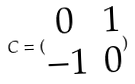<formula> <loc_0><loc_0><loc_500><loc_500>C = ( \begin{matrix} 0 & 1 \\ - 1 & 0 \end{matrix} )</formula> 